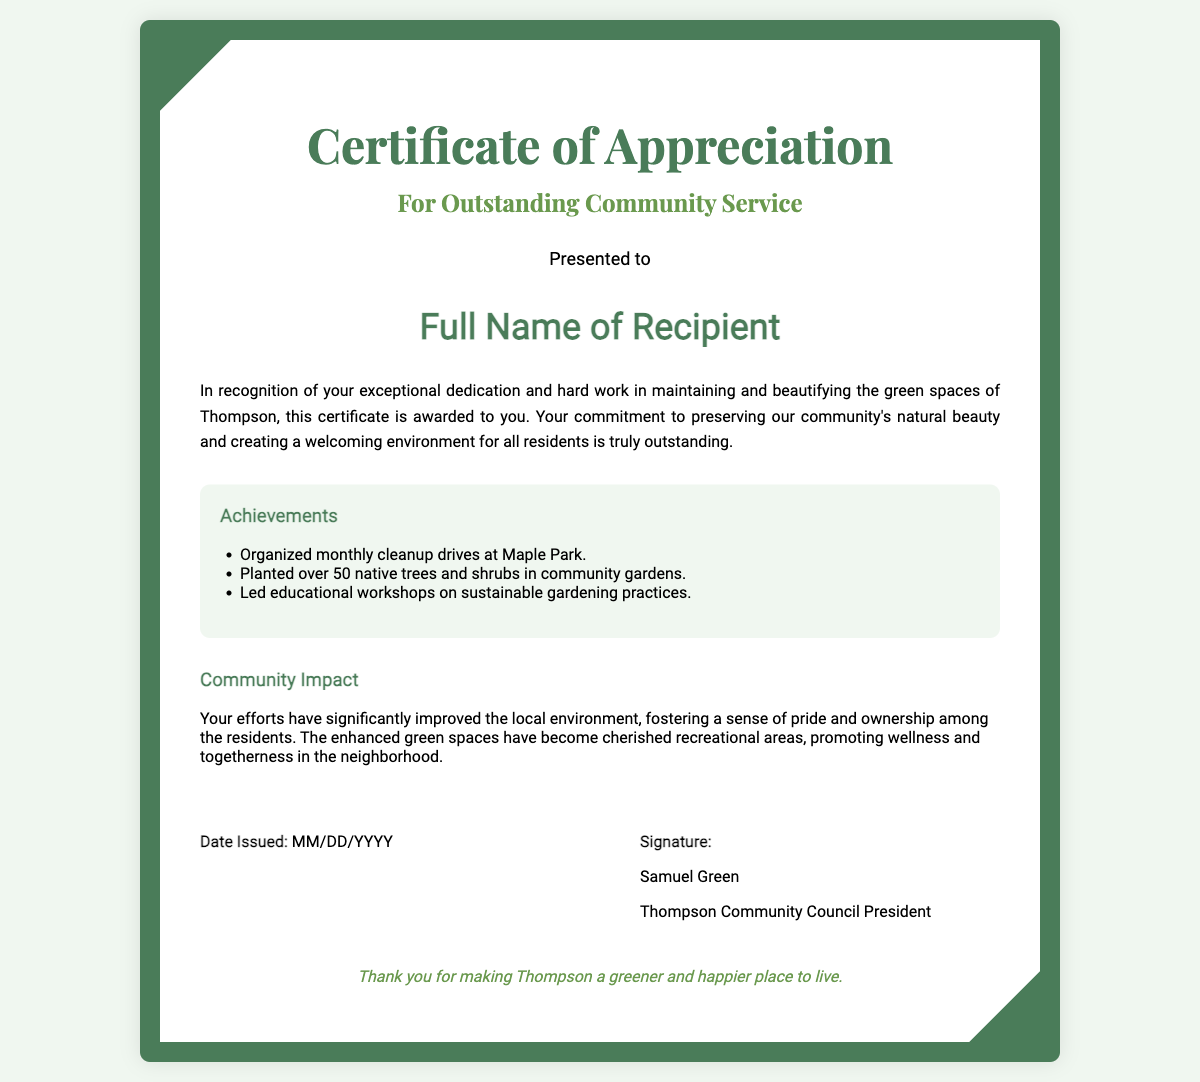What is the title of the certificate? The title, prominently displayed at the top, identifies the purpose of the document.
Answer: Certificate of Appreciation Who is the recipient of the certificate? The recipient's name is specifically highlighted in the document, indicating to whom the certificate is presented.
Answer: Full Name of Recipient What is the date issued format in the document? The document specifies a placeholder for the date issued, indicating the format it should follow.
Answer: MM/DD/YYYY Who signed the certificate? The signature section includes the name of the individual who authorized the certificate.
Answer: Samuel Green What is one of the achievements listed for the recipient? The achievements section outlines specific contributions made by the recipient, showcasing their impact.
Answer: Organized monthly cleanup drives at Maple Park What is the impact of the recipient's efforts mentioned in the document? The community impact statement reflects on the broader influence of the recipient's actions within the neighborhood.
Answer: Improved the local environment What is the salutation used in the certificate? The salutation serves as a formal introduction to the recipient's recognition in the document.
Answer: Presented to What does the footer of the certificate express? The footer adds a personal touch, thanking the recipient for their contributions to the community.
Answer: Thank you for making Thompson a greener and happier place to live What is the main color theme of the certificate design? The color scheme is represented through the main elements of design, including the borders and text.
Answer: Green 